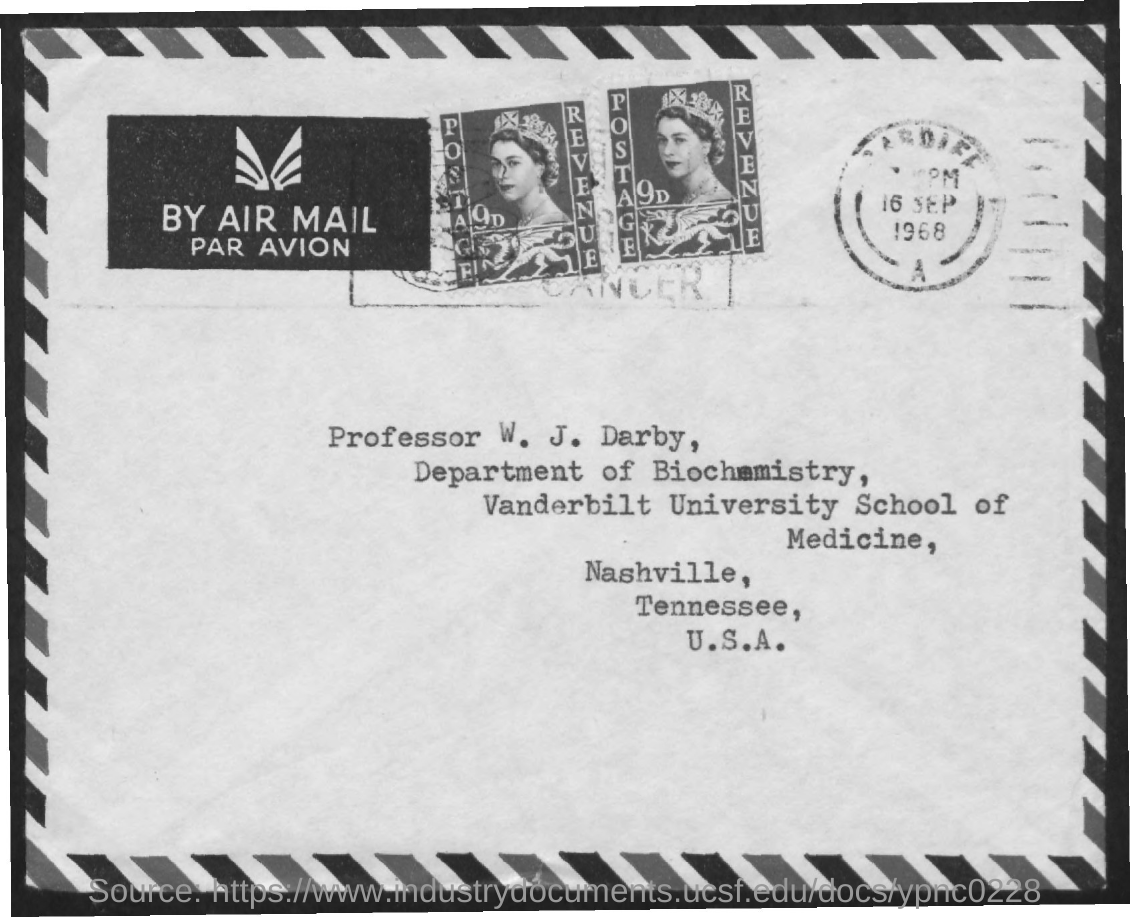Draw attention to some important aspects in this diagram. The letter is addressed to Professor W. J. Darby. 